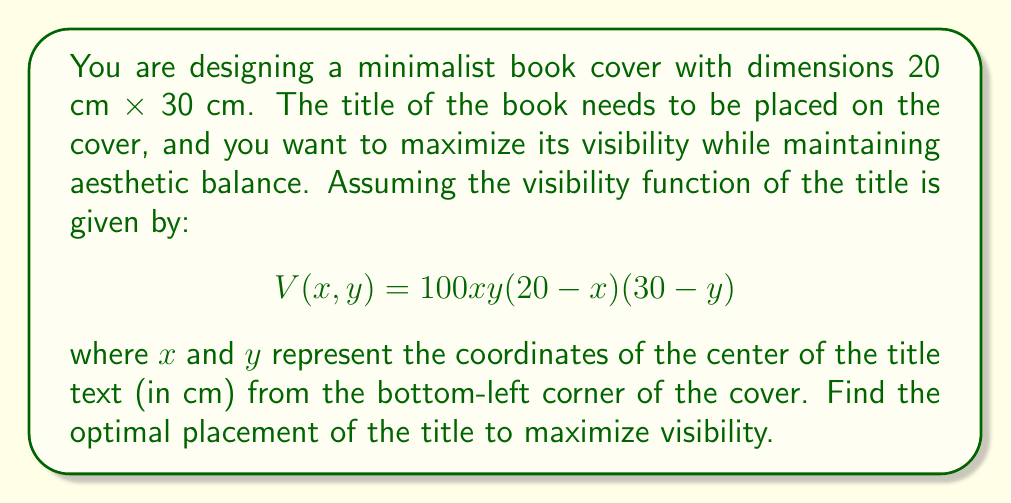Solve this math problem. To find the optimal placement of the title, we need to maximize the visibility function $V(x, y)$. This is a problem of finding the maximum of a multivariable function, which we can solve using partial derivatives.

1. First, let's find the partial derivatives of $V$ with respect to $x$ and $y$:

   $$\frac{\partial V}{\partial x} = 100y(20-x)(30-y) - 100xy(30-y)$$
   $$\frac{\partial V}{\partial y} = 100x(20-x)(30-y) - 100xy(20-x)$$

2. To find the critical points, we set both partial derivatives to zero:

   $$\frac{\partial V}{\partial x} = 0: y(20-x)(30-y) - xy(30-y) = 0$$
   $$\frac{\partial V}{\partial y} = 0: x(20-x)(30-y) - xy(20-x) = 0$$

3. Simplifying these equations:

   $$y(600 - 30x - 20y + xy) = 0$$
   $$x(600 - 30y - 20x + xy) = 0$$

4. From these equations, we can see that either $x = 0$, $y = 0$, or the terms in parentheses are zero. Since $x = 0$ or $y = 0$ would place the title on the edge of the cover (which is unlikely to be optimal), we focus on solving:

   $$600 - 30x - 20y + xy = 0$$

5. This equation is symmetric in $x$ and $y$, suggesting that the optimal point might have $x = y$. Substituting $y = x$:

   $$600 - 30x - 20x + x^2 = 0$$
   $$x^2 - 50x + 600 = 0$$

6. Solving this quadratic equation:

   $$x = \frac{50 \pm \sqrt{2500 - 2400}}{2} = \frac{50 \pm 10}{2}$$

   The solution $x = 30$ is outside our domain, so we take $x = y = 10$.

7. To confirm this is a maximum, we can check the second partial derivatives:

   $$\frac{\partial^2 V}{\partial x^2} = -200y(30-y)$$
   $$\frac{\partial^2 V}{\partial y^2} = -200x(20-x)$$
   $$\frac{\partial^2 V}{\partial x\partial y} = 100(600 - 60x - 60y + 2xy)$$

   At $x = y = 10$, these evaluate to negative values, confirming a local maximum.

Therefore, the optimal placement for the title is at coordinates (10 cm, 10 cm) from the bottom-left corner of the cover.
Answer: The optimal placement for the book title to maximize visibility is at coordinates (10 cm, 10 cm) from the bottom-left corner of the cover. 